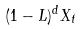<formula> <loc_0><loc_0><loc_500><loc_500>( 1 - L ) ^ { d } X _ { t }</formula> 